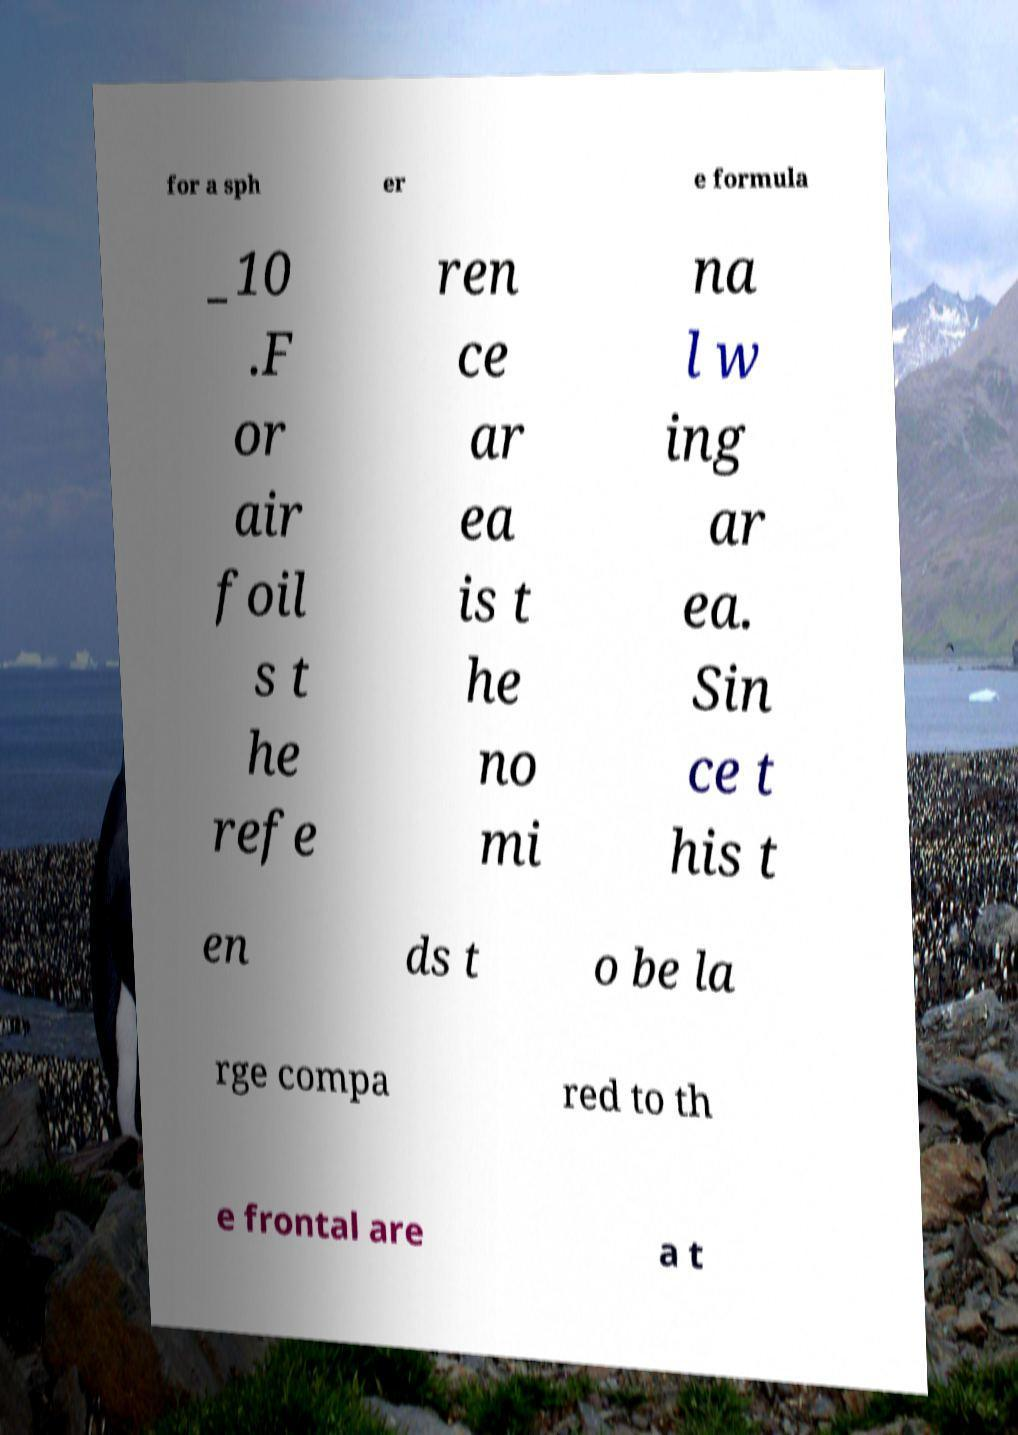Please read and relay the text visible in this image. What does it say? for a sph er e formula _10 .F or air foil s t he refe ren ce ar ea is t he no mi na l w ing ar ea. Sin ce t his t en ds t o be la rge compa red to th e frontal are a t 